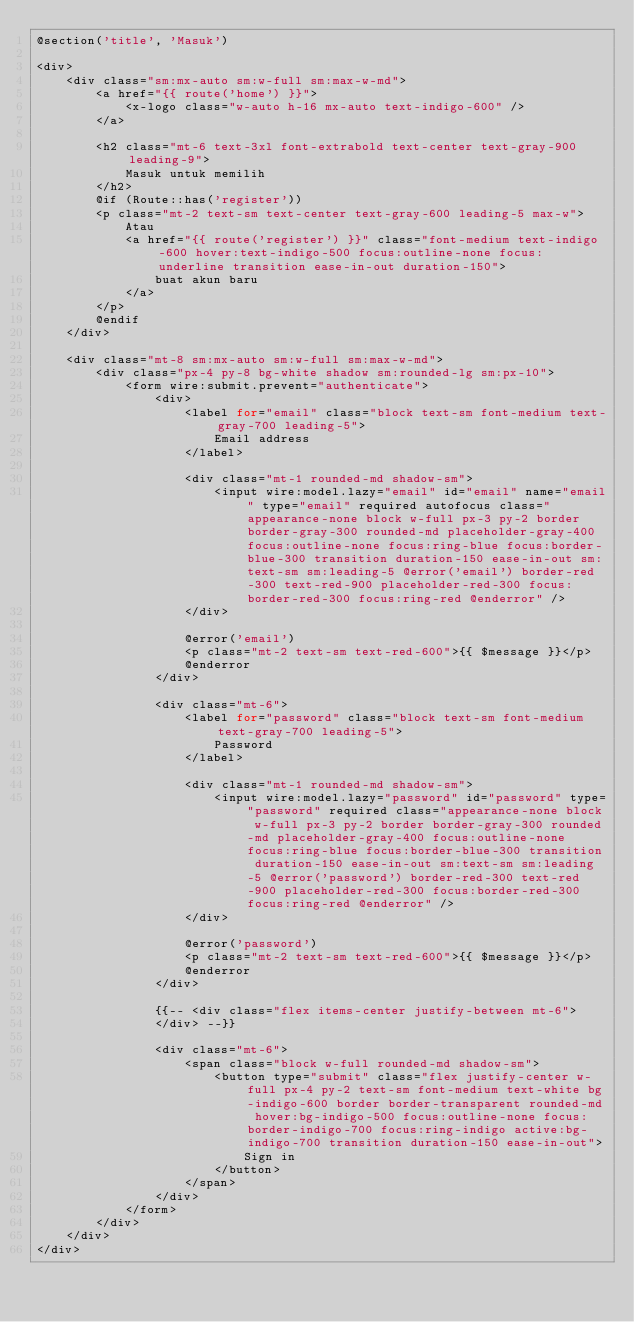<code> <loc_0><loc_0><loc_500><loc_500><_PHP_>@section('title', 'Masuk')

<div>
    <div class="sm:mx-auto sm:w-full sm:max-w-md">
        <a href="{{ route('home') }}">
            <x-logo class="w-auto h-16 mx-auto text-indigo-600" />
        </a>

        <h2 class="mt-6 text-3xl font-extrabold text-center text-gray-900 leading-9">
            Masuk untuk memilih
        </h2>
        @if (Route::has('register'))
        <p class="mt-2 text-sm text-center text-gray-600 leading-5 max-w">
            Atau
            <a href="{{ route('register') }}" class="font-medium text-indigo-600 hover:text-indigo-500 focus:outline-none focus:underline transition ease-in-out duration-150">
                buat akun baru
            </a>
        </p>
        @endif
    </div>

    <div class="mt-8 sm:mx-auto sm:w-full sm:max-w-md">
        <div class="px-4 py-8 bg-white shadow sm:rounded-lg sm:px-10">
            <form wire:submit.prevent="authenticate">
                <div>
                    <label for="email" class="block text-sm font-medium text-gray-700 leading-5">
                        Email address
                    </label>

                    <div class="mt-1 rounded-md shadow-sm">
                        <input wire:model.lazy="email" id="email" name="email" type="email" required autofocus class="appearance-none block w-full px-3 py-2 border border-gray-300 rounded-md placeholder-gray-400 focus:outline-none focus:ring-blue focus:border-blue-300 transition duration-150 ease-in-out sm:text-sm sm:leading-5 @error('email') border-red-300 text-red-900 placeholder-red-300 focus:border-red-300 focus:ring-red @enderror" />
                    </div>

                    @error('email')
                    <p class="mt-2 text-sm text-red-600">{{ $message }}</p>
                    @enderror
                </div>

                <div class="mt-6">
                    <label for="password" class="block text-sm font-medium text-gray-700 leading-5">
                        Password
                    </label>

                    <div class="mt-1 rounded-md shadow-sm">
                        <input wire:model.lazy="password" id="password" type="password" required class="appearance-none block w-full px-3 py-2 border border-gray-300 rounded-md placeholder-gray-400 focus:outline-none focus:ring-blue focus:border-blue-300 transition duration-150 ease-in-out sm:text-sm sm:leading-5 @error('password') border-red-300 text-red-900 placeholder-red-300 focus:border-red-300 focus:ring-red @enderror" />
                    </div>

                    @error('password')
                    <p class="mt-2 text-sm text-red-600">{{ $message }}</p>
                    @enderror
                </div>

                {{-- <div class="flex items-center justify-between mt-6">
                </div> --}}

                <div class="mt-6">
                    <span class="block w-full rounded-md shadow-sm">
                        <button type="submit" class="flex justify-center w-full px-4 py-2 text-sm font-medium text-white bg-indigo-600 border border-transparent rounded-md hover:bg-indigo-500 focus:outline-none focus:border-indigo-700 focus:ring-indigo active:bg-indigo-700 transition duration-150 ease-in-out">
                            Sign in
                        </button>
                    </span>
                </div>
            </form>
        </div>
    </div>
</div></code> 